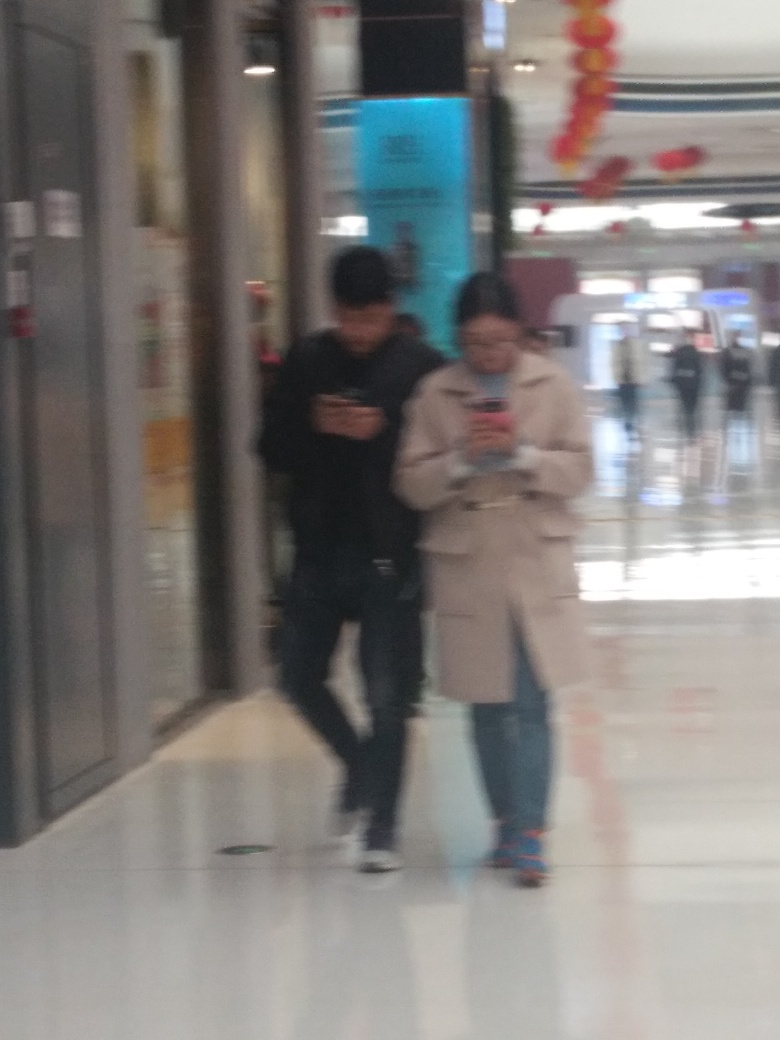What are the two individuals in the image doing? The two individuals seem to be walking through an indoor space, and both are engrossed in their smartphones, possibly texting, reading, or navigating.  Is there anything that can be inferred about the people or their activities despite the poor image quality? While specific details are hard to make out, their posture and focus on their phones suggest they are not interacting with each other at the moment. This scene could be reflective of contemporary social dynamics where digital devices often capture our attention in public spaces. 